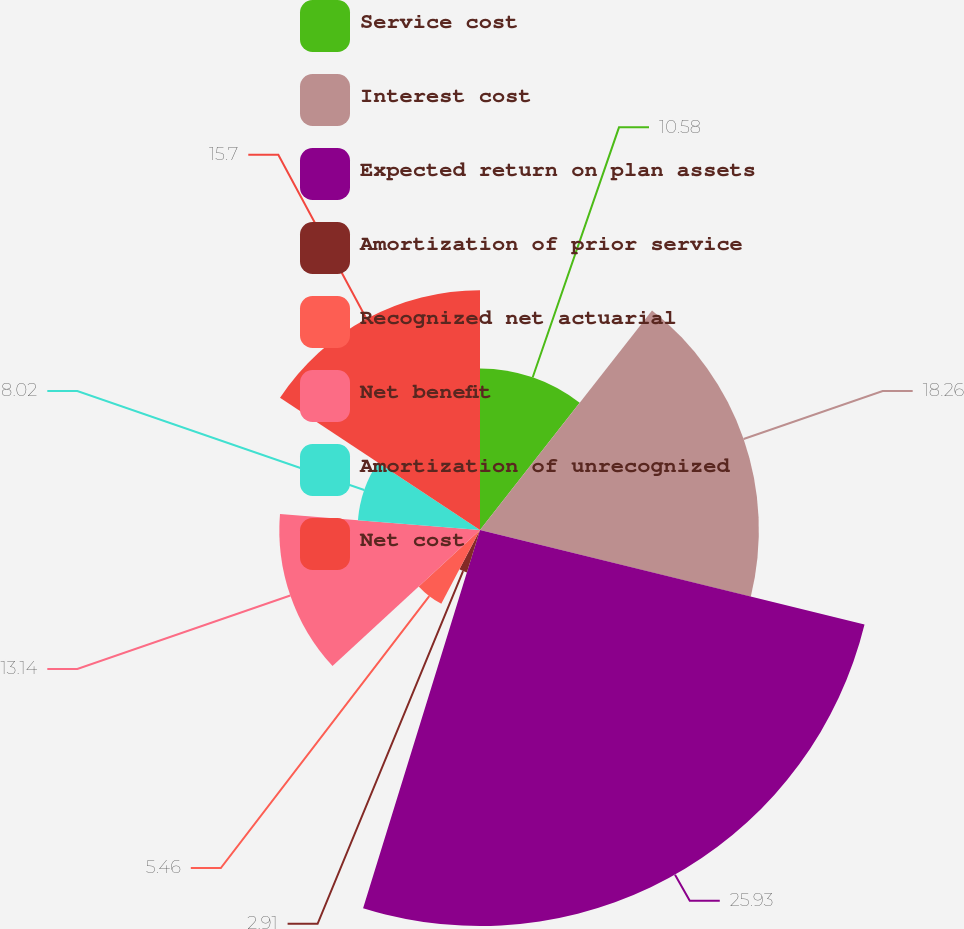<chart> <loc_0><loc_0><loc_500><loc_500><pie_chart><fcel>Service cost<fcel>Interest cost<fcel>Expected return on plan assets<fcel>Amortization of prior service<fcel>Recognized net actuarial<fcel>Net benefit<fcel>Amortization of unrecognized<fcel>Net cost<nl><fcel>10.58%<fcel>18.26%<fcel>25.93%<fcel>2.91%<fcel>5.46%<fcel>13.14%<fcel>8.02%<fcel>15.7%<nl></chart> 